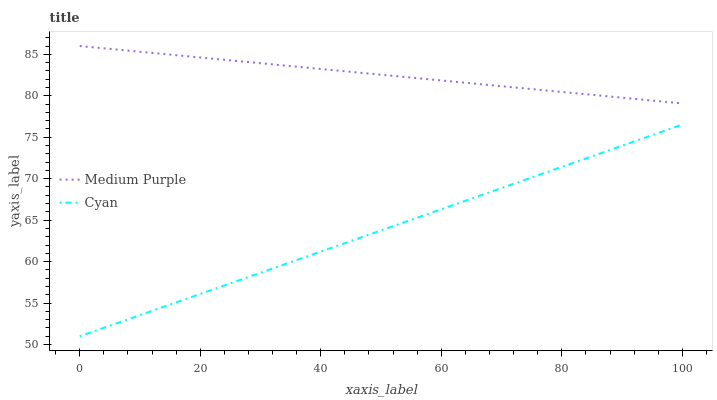Does Cyan have the minimum area under the curve?
Answer yes or no. Yes. Does Medium Purple have the maximum area under the curve?
Answer yes or no. Yes. Does Cyan have the maximum area under the curve?
Answer yes or no. No. Is Cyan the smoothest?
Answer yes or no. Yes. Is Medium Purple the roughest?
Answer yes or no. Yes. Is Cyan the roughest?
Answer yes or no. No. Does Cyan have the lowest value?
Answer yes or no. Yes. Does Medium Purple have the highest value?
Answer yes or no. Yes. Does Cyan have the highest value?
Answer yes or no. No. Is Cyan less than Medium Purple?
Answer yes or no. Yes. Is Medium Purple greater than Cyan?
Answer yes or no. Yes. Does Cyan intersect Medium Purple?
Answer yes or no. No. 